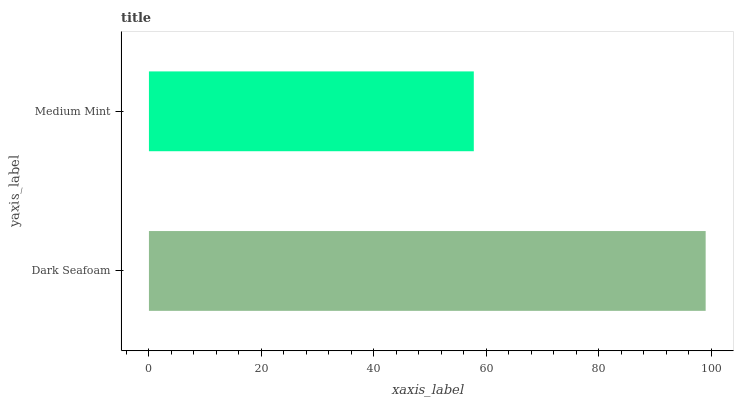Is Medium Mint the minimum?
Answer yes or no. Yes. Is Dark Seafoam the maximum?
Answer yes or no. Yes. Is Medium Mint the maximum?
Answer yes or no. No. Is Dark Seafoam greater than Medium Mint?
Answer yes or no. Yes. Is Medium Mint less than Dark Seafoam?
Answer yes or no. Yes. Is Medium Mint greater than Dark Seafoam?
Answer yes or no. No. Is Dark Seafoam less than Medium Mint?
Answer yes or no. No. Is Dark Seafoam the high median?
Answer yes or no. Yes. Is Medium Mint the low median?
Answer yes or no. Yes. Is Medium Mint the high median?
Answer yes or no. No. Is Dark Seafoam the low median?
Answer yes or no. No. 